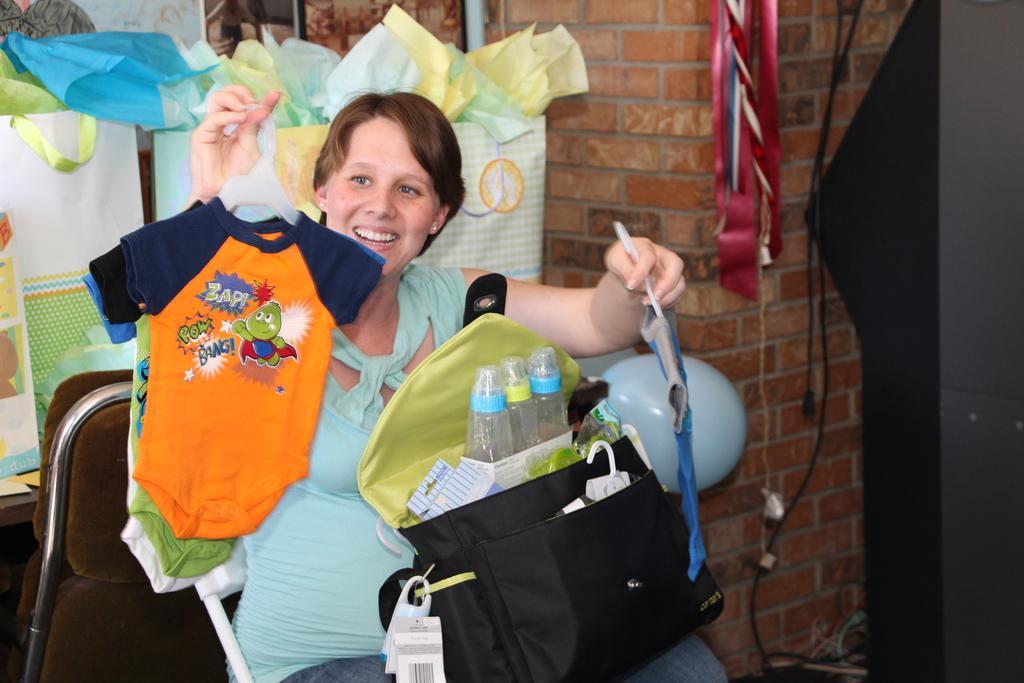Could you give a brief overview of what you see in this image? In this image I see a woman who is sitting and she is holding clothes in her hands, I can also see there is a bag on her. In the background I see the bags and the wall. 